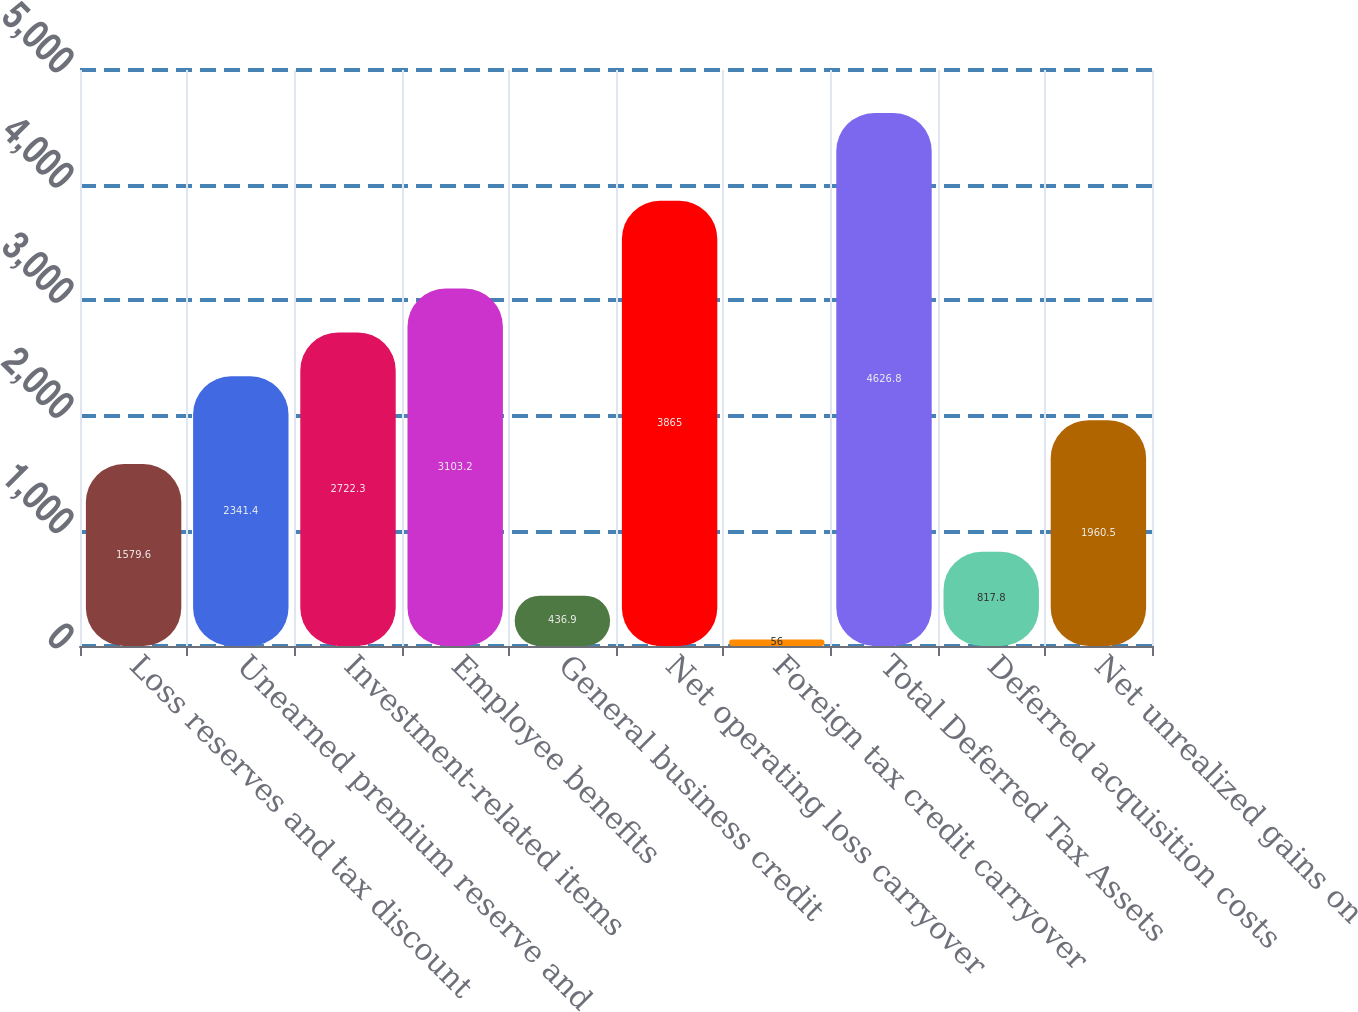Convert chart to OTSL. <chart><loc_0><loc_0><loc_500><loc_500><bar_chart><fcel>Loss reserves and tax discount<fcel>Unearned premium reserve and<fcel>Investment-related items<fcel>Employee benefits<fcel>General business credit<fcel>Net operating loss carryover<fcel>Foreign tax credit carryover<fcel>Total Deferred Tax Assets<fcel>Deferred acquisition costs<fcel>Net unrealized gains on<nl><fcel>1579.6<fcel>2341.4<fcel>2722.3<fcel>3103.2<fcel>436.9<fcel>3865<fcel>56<fcel>4626.8<fcel>817.8<fcel>1960.5<nl></chart> 